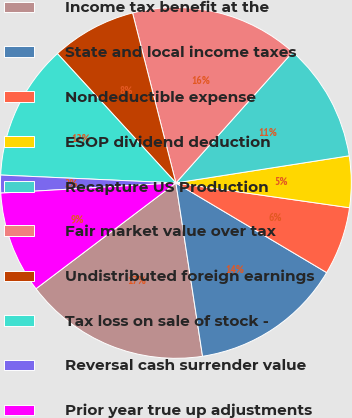<chart> <loc_0><loc_0><loc_500><loc_500><pie_chart><fcel>Income tax benefit at the<fcel>State and local income taxes<fcel>Nondeductible expense<fcel>ESOP dividend deduction<fcel>Recapture US Production<fcel>Fair market value over tax<fcel>Undistributed foreign earnings<fcel>Tax loss on sale of stock -<fcel>Reversal cash surrender value<fcel>Prior year true up adjustments<nl><fcel>17.12%<fcel>14.03%<fcel>6.28%<fcel>4.73%<fcel>10.93%<fcel>15.57%<fcel>7.83%<fcel>12.48%<fcel>1.64%<fcel>9.38%<nl></chart> 